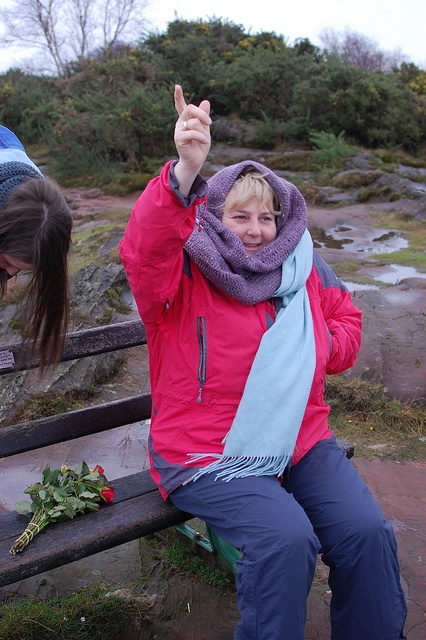Describe the objects in this image and their specific colors. I can see people in white, navy, brown, blue, and black tones, bench in white, black, and gray tones, and people in white, black, and gray tones in this image. 